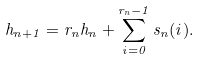<formula> <loc_0><loc_0><loc_500><loc_500>h _ { n + 1 } = r _ { n } h _ { n } + \sum _ { i = 0 } ^ { r _ { n } - 1 } s _ { n } ( i ) .</formula> 